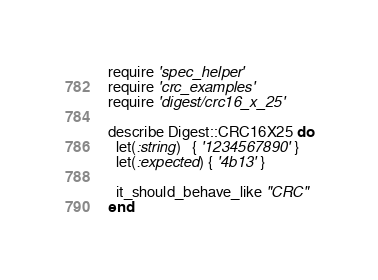Convert code to text. <code><loc_0><loc_0><loc_500><loc_500><_Ruby_>require 'spec_helper'
require 'crc_examples'
require 'digest/crc16_x_25'

describe Digest::CRC16X25 do
  let(:string)   { '1234567890' }
  let(:expected) { '4b13' }

  it_should_behave_like "CRC"
end
</code> 